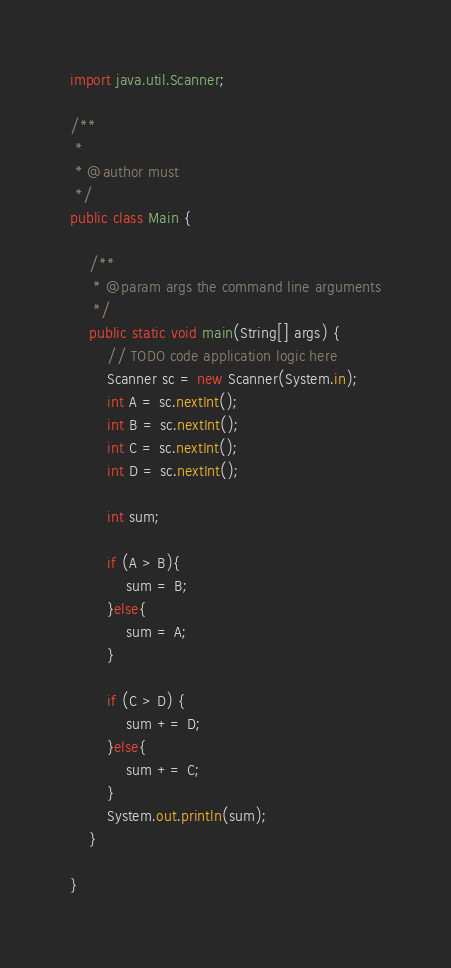Convert code to text. <code><loc_0><loc_0><loc_500><loc_500><_Java_>import java.util.Scanner;

/**
 *
 * @author must
 */
public class Main {

    /**
     * @param args the command line arguments
     */
    public static void main(String[] args) {
        // TODO code application logic here
        Scanner sc = new Scanner(System.in);
        int A = sc.nextInt();
        int B = sc.nextInt();
        int C = sc.nextInt();
        int D = sc.nextInt();
        
        int sum;
        
        if (A > B){
            sum = B;
        }else{
            sum = A;
        }
        
        if (C > D) {
            sum += D;
        }else{
            sum += C;
        }
        System.out.println(sum);
    }
    
}
</code> 